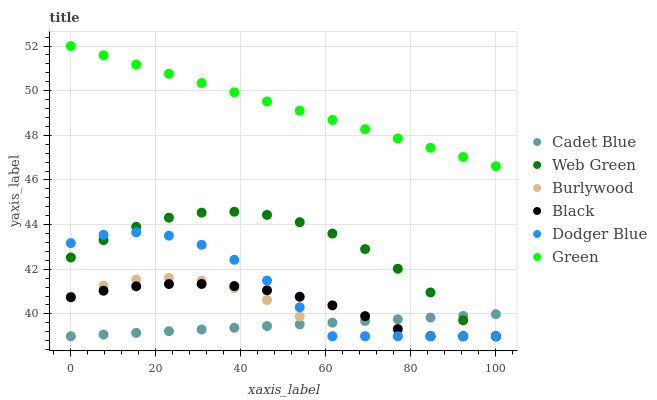Does Cadet Blue have the minimum area under the curve?
Answer yes or no. Yes. Does Green have the maximum area under the curve?
Answer yes or no. Yes. Does Burlywood have the minimum area under the curve?
Answer yes or no. No. Does Burlywood have the maximum area under the curve?
Answer yes or no. No. Is Cadet Blue the smoothest?
Answer yes or no. Yes. Is Dodger Blue the roughest?
Answer yes or no. Yes. Is Green the smoothest?
Answer yes or no. No. Is Green the roughest?
Answer yes or no. No. Does Cadet Blue have the lowest value?
Answer yes or no. Yes. Does Green have the lowest value?
Answer yes or no. No. Does Green have the highest value?
Answer yes or no. Yes. Does Burlywood have the highest value?
Answer yes or no. No. Is Burlywood less than Green?
Answer yes or no. Yes. Is Green greater than Web Green?
Answer yes or no. Yes. Does Black intersect Burlywood?
Answer yes or no. Yes. Is Black less than Burlywood?
Answer yes or no. No. Is Black greater than Burlywood?
Answer yes or no. No. Does Burlywood intersect Green?
Answer yes or no. No. 